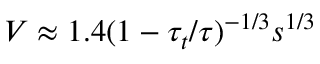<formula> <loc_0><loc_0><loc_500><loc_500>V \approx 1 . 4 ( 1 - \tau _ { t } / \tau ) ^ { - 1 / 3 } s ^ { 1 / 3 }</formula> 